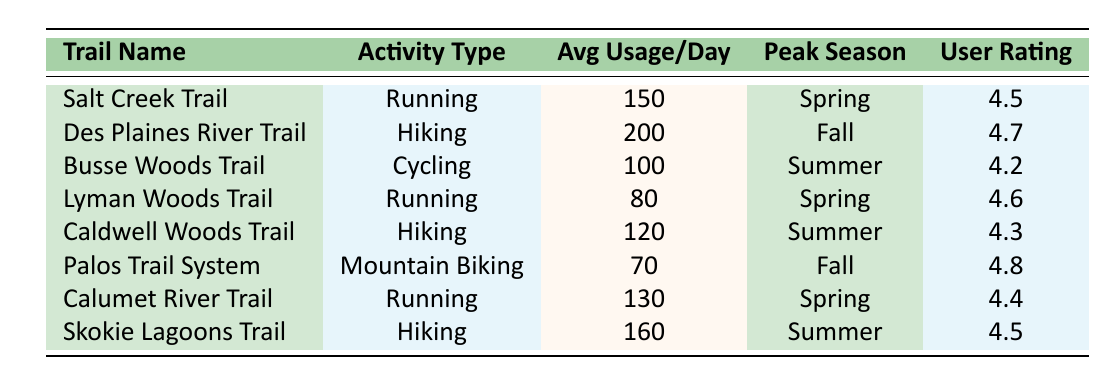What is the user feedback rating for Skokie Lagoons Trail? The user feedback rating for Skokie Lagoons Trail is provided directly in the table. It is located in the row corresponding to Skokie Lagoons Trail under the "User Rating" column.
Answer: 4.5 Which trail has the highest average usage per day? To find the highest average usage, I need to compare the values in the "Avg Usage/Day" column. Des Plaines River Trail has the highest average usage of 200.
Answer: Des Plaines River Trail Are there more hiking trails than running trails in the data? By counting the number of times "Hiking" and "Running" appear in the "Activity Type" column, I find that there are 4 hiking trails (Des Plaines River Trail, Caldwell Woods Trail, Skokie Lagoons Trail) and 3 running trails (Salt Creek Trail, Lyman Woods Trail, Calumet River Trail). Four is greater than three, so the statement is true.
Answer: Yes What is the average usage per day of all running trails? I sum the average daily usage of running trails: Salt Creek Trail (150) + Lyman Woods Trail (80) + Calumet River Trail (130) = 360. There are 3 running trails, so the average is 360/3 = 120.
Answer: 120 Which trail has a user rating of 4.6, and what is its activity type? I search for the rating of 4.6 in the "User Rating" column. This rating corresponds to Lyman Woods Trail, which has "Running" listed as its activity type.
Answer: Lyman Woods Trail, Running What is the peak season for the trail with the least average usage per day? The trail with the least average usage is Palos Trail System at 70. Looking at that row, I see that its peak season is "Fall."
Answer: Fall Are there any trails used for mountain biking? I check the "Activity Type" column for "Mountain Biking" and find that Palos Trail System is the only trail listed with that activity type.
Answer: Yes What is the total average usage per day of all trails categorized under hiking? I sum the average daily usage of the hiking trails: Des Plaines River Trail (200) + Caldwell Woods Trail (120) + Skokie Lagoons Trail (160) = 480. There are 3 hiking trails, so the total is 480.
Answer: 480 